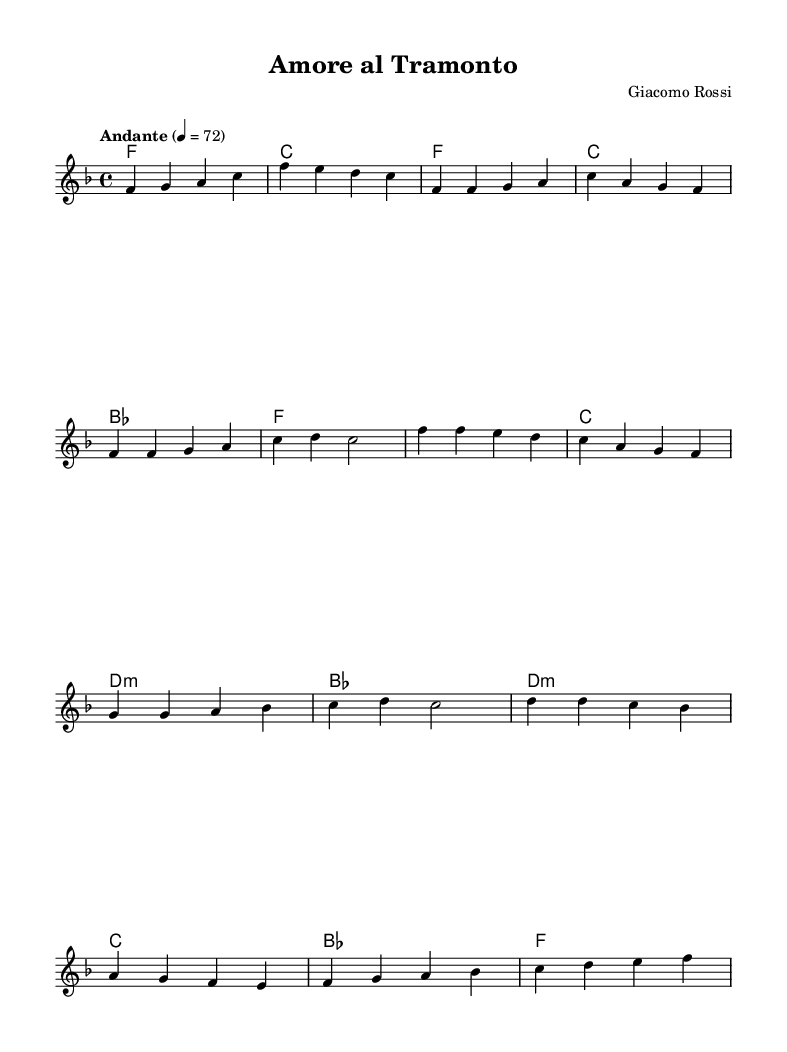What is the key signature of this music? The key signature is F major, which has one flat (B flat). This is identified by looking at the key signature at the beginning of the staff, which indicates the notes affected by flats or sharps.
Answer: F major What is the time signature of this piece? The time signature is 4/4, as indicated at the beginning of the score. This means there are four beats in each measure, and the quarter note receives one beat.
Answer: 4/4 What is the tempo marking for this music? The tempo marking is "Andante," which indicates a moderately slow tempo. This can be found in the tempo instruction at the beginning of the score.
Answer: Andante How many measures are in the chorus section? The chorus section consists of four measures, which can be determined by counting the measures specifically indicated by the melody line for the chorus.
Answer: 4 What type of chords are used in the chorus? The chords in the chorus include F major, C major, D minor, and B flat major. These are listed under the chorus section in the chord names part of the score.
Answer: F, C, D:m, B What is the structure of this piece? The structure of this piece follows an Intro, Verse, Chorus, and Bridge format, as indicated by the sections marked and the overall flow of the melody and harmonies.
Answer: Intro, Verse, Chorus, Bridge 